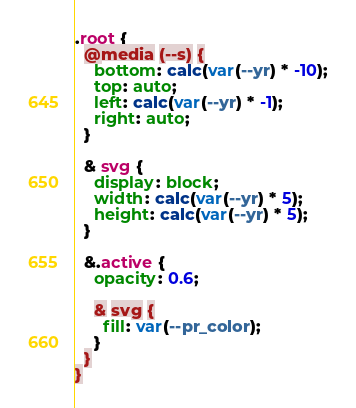Convert code to text. <code><loc_0><loc_0><loc_500><loc_500><_CSS_>.root {
  @media (--s) {
    bottom: calc(var(--yr) * -10);
    top: auto;
    left: calc(var(--yr) * -1);
    right: auto;
  }

  & svg {
    display: block;
    width: calc(var(--yr) * 5);
    height: calc(var(--yr) * 5);
  }

  &.active {
    opacity: 0.6;

    & svg {
      fill: var(--pr_color);
    }
  }
}
</code> 